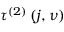Convert formula to latex. <formula><loc_0><loc_0><loc_500><loc_500>\tau ^ { \left ( 2 \right ) } \left ( j , \nu \right )</formula> 